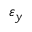<formula> <loc_0><loc_0><loc_500><loc_500>\varepsilon _ { y }</formula> 